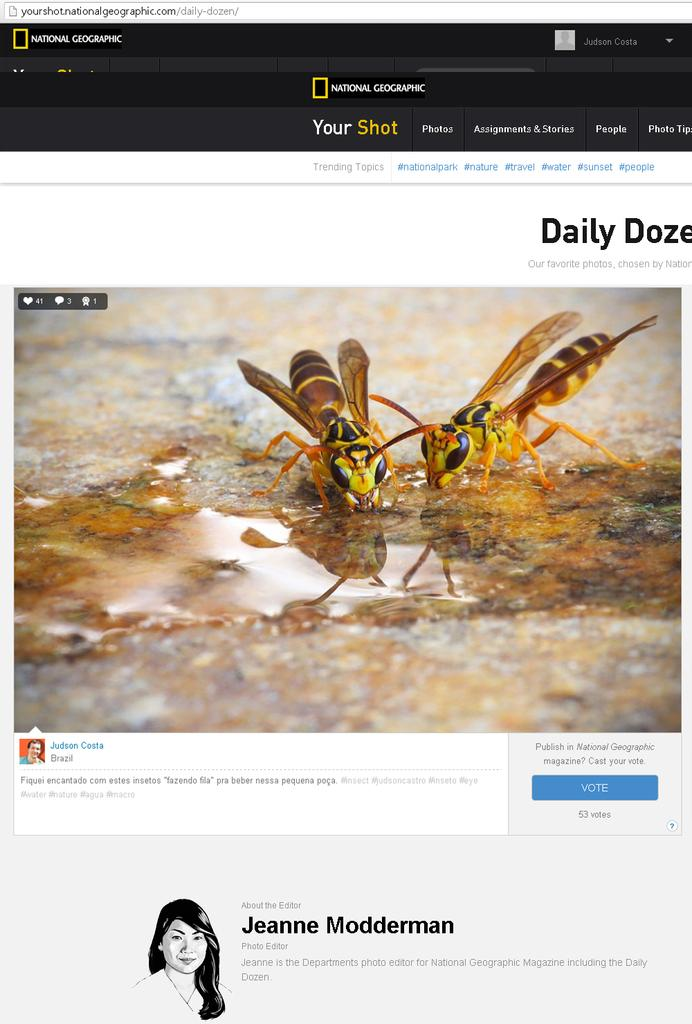What type of content is displayed on the webpage? The image is a webpage, and it contains an image of insects and texts. Can you describe the image of insects on the webpage? The image of insects on the webpage shows various insects. What other type of content can be found on the webpage besides the image of insects? There are texts on the webpage. How many airplanes are visible in the image of insects on the webpage? There are no airplanes visible in the image of insects on the webpage, as it only contains images of insects. Can you describe the lizards and frogs in the image of insects on the webpage? There are no lizards or frogs present in the image of insects on the webpage, as it only contains images of insects. 